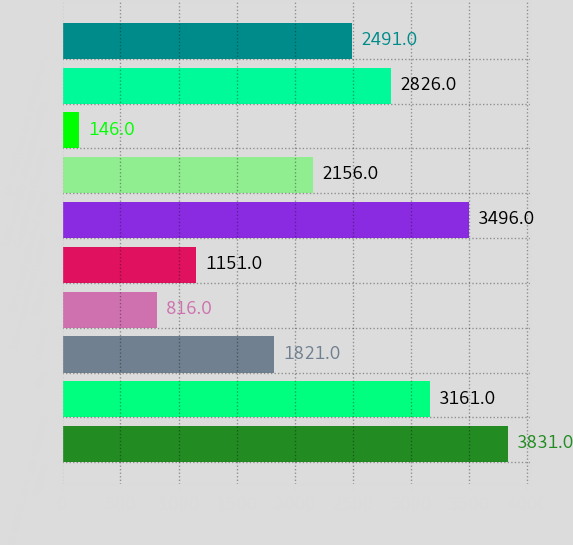Convert chart to OTSL. <chart><loc_0><loc_0><loc_500><loc_500><bar_chart><fcel>Millions<fcel>Rail and other track material<fcel>Ties<fcel>Ballast<fcel>Other a<fcel>Total road infrastructure<fcel>Line expansion and other<fcel>Commercial facilities<fcel>Total capacity and commercial<fcel>Locomotives and freight cars<nl><fcel>3831<fcel>3161<fcel>1821<fcel>816<fcel>1151<fcel>3496<fcel>2156<fcel>146<fcel>2826<fcel>2491<nl></chart> 